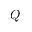<formula> <loc_0><loc_0><loc_500><loc_500>Q</formula> 